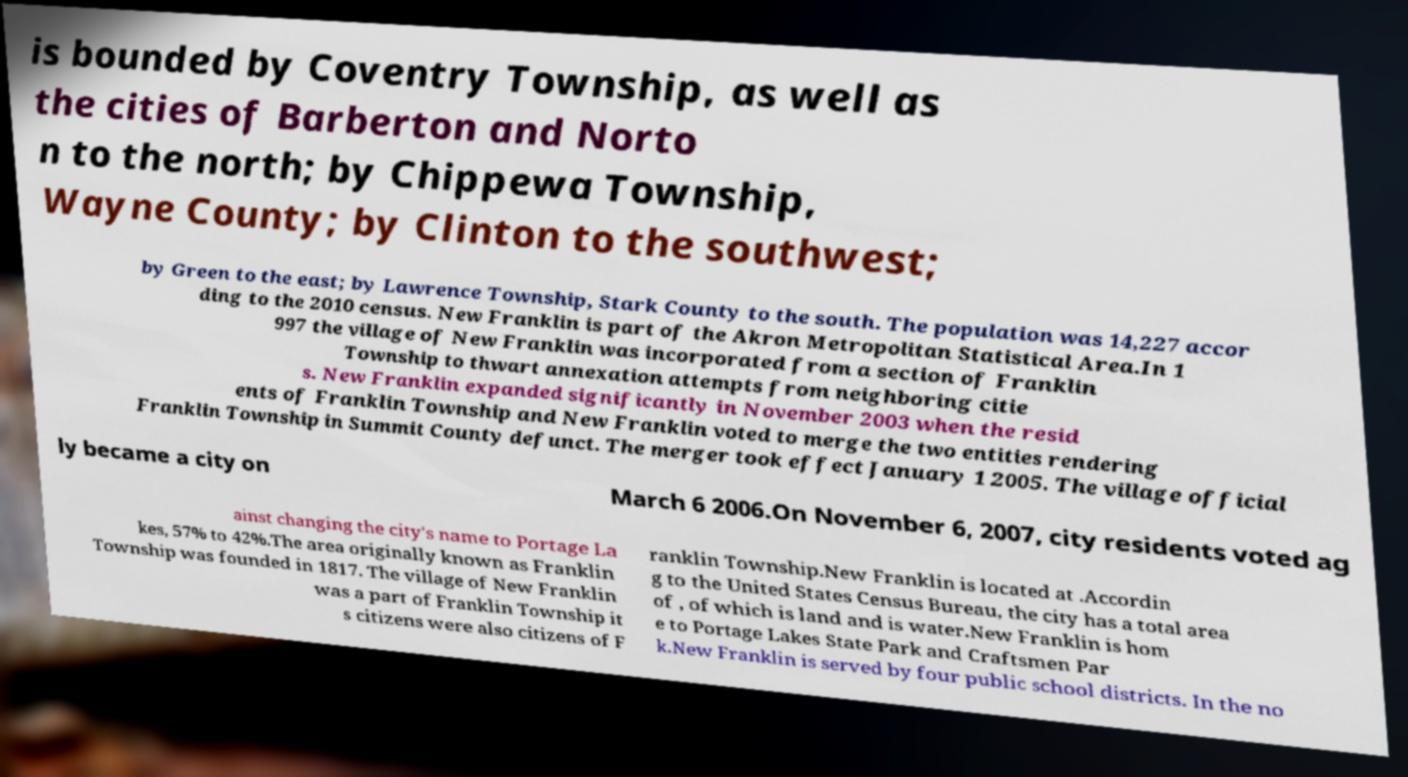Can you read and provide the text displayed in the image?This photo seems to have some interesting text. Can you extract and type it out for me? is bounded by Coventry Township, as well as the cities of Barberton and Norto n to the north; by Chippewa Township, Wayne County; by Clinton to the southwest; by Green to the east; by Lawrence Township, Stark County to the south. The population was 14,227 accor ding to the 2010 census. New Franklin is part of the Akron Metropolitan Statistical Area.In 1 997 the village of New Franklin was incorporated from a section of Franklin Township to thwart annexation attempts from neighboring citie s. New Franklin expanded significantly in November 2003 when the resid ents of Franklin Township and New Franklin voted to merge the two entities rendering Franklin Township in Summit County defunct. The merger took effect January 1 2005. The village official ly became a city on March 6 2006.On November 6, 2007, city residents voted ag ainst changing the city's name to Portage La kes, 57% to 42%.The area originally known as Franklin Township was founded in 1817. The village of New Franklin was a part of Franklin Township it s citizens were also citizens of F ranklin Township.New Franklin is located at .Accordin g to the United States Census Bureau, the city has a total area of , of which is land and is water.New Franklin is hom e to Portage Lakes State Park and Craftsmen Par k.New Franklin is served by four public school districts. In the no 